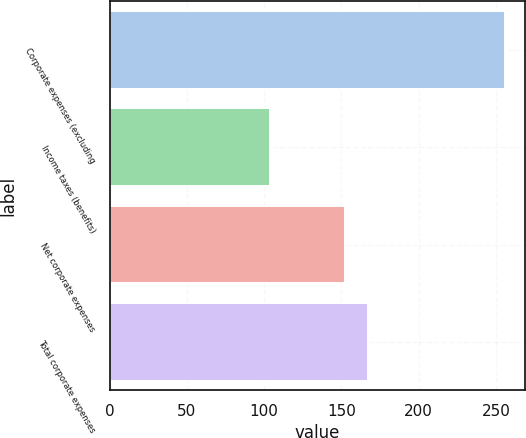<chart> <loc_0><loc_0><loc_500><loc_500><bar_chart><fcel>Corporate expenses (excluding<fcel>Income taxes (benefits)<fcel>Net corporate expenses<fcel>Total corporate expenses<nl><fcel>256<fcel>104<fcel>152<fcel>167.2<nl></chart> 